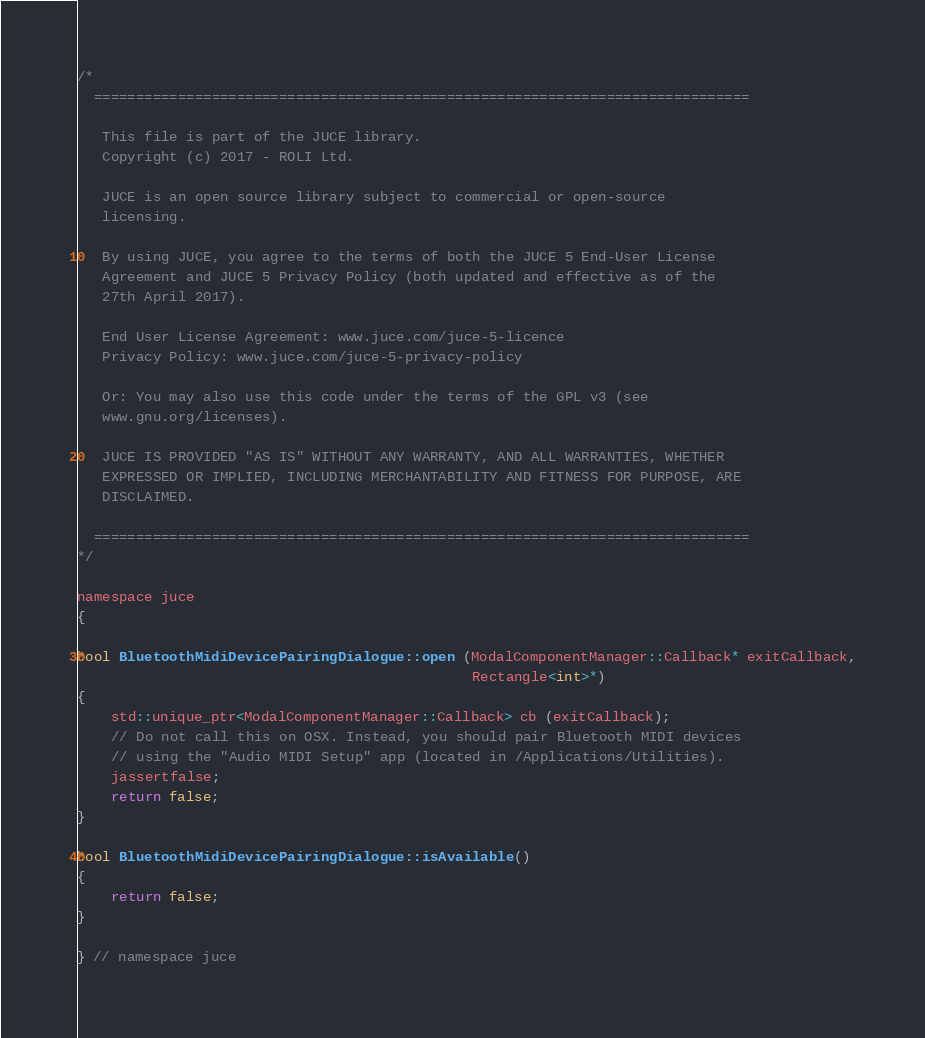Convert code to text. <code><loc_0><loc_0><loc_500><loc_500><_ObjectiveC_>/*
  ==============================================================================

   This file is part of the JUCE library.
   Copyright (c) 2017 - ROLI Ltd.

   JUCE is an open source library subject to commercial or open-source
   licensing.

   By using JUCE, you agree to the terms of both the JUCE 5 End-User License
   Agreement and JUCE 5 Privacy Policy (both updated and effective as of the
   27th April 2017).

   End User License Agreement: www.juce.com/juce-5-licence
   Privacy Policy: www.juce.com/juce-5-privacy-policy

   Or: You may also use this code under the terms of the GPL v3 (see
   www.gnu.org/licenses).

   JUCE IS PROVIDED "AS IS" WITHOUT ANY WARRANTY, AND ALL WARRANTIES, WHETHER
   EXPRESSED OR IMPLIED, INCLUDING MERCHANTABILITY AND FITNESS FOR PURPOSE, ARE
   DISCLAIMED.

  ==============================================================================
*/

namespace juce
{

bool BluetoothMidiDevicePairingDialogue::open (ModalComponentManager::Callback* exitCallback,
                                               Rectangle<int>*)
{
    std::unique_ptr<ModalComponentManager::Callback> cb (exitCallback);
    // Do not call this on OSX. Instead, you should pair Bluetooth MIDI devices
    // using the "Audio MIDI Setup" app (located in /Applications/Utilities).
    jassertfalse;
    return false;
}

bool BluetoothMidiDevicePairingDialogue::isAvailable()
{
    return false;
}

} // namespace juce
</code> 